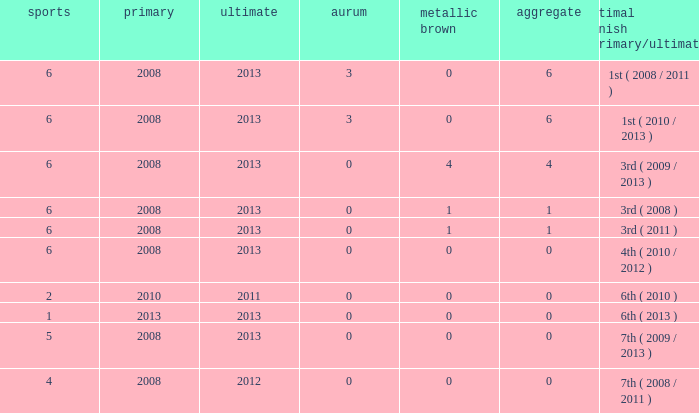Could you parse the entire table as a dict? {'header': ['sports', 'primary', 'ultimate', 'aurum', 'metallic brown', 'aggregate', 'optimal finish (primary/ultimate)'], 'rows': [['6', '2008', '2013', '3', '0', '6', '1st ( 2008 / 2011 )'], ['6', '2008', '2013', '3', '0', '6', '1st ( 2010 / 2013 )'], ['6', '2008', '2013', '0', '4', '4', '3rd ( 2009 / 2013 )'], ['6', '2008', '2013', '0', '1', '1', '3rd ( 2008 )'], ['6', '2008', '2013', '0', '1', '1', '3rd ( 2011 )'], ['6', '2008', '2013', '0', '0', '0', '4th ( 2010 / 2012 )'], ['2', '2010', '2011', '0', '0', '0', '6th ( 2010 )'], ['1', '2013', '2013', '0', '0', '0', '6th ( 2013 )'], ['5', '2008', '2013', '0', '0', '0', '7th ( 2009 / 2013 )'], ['4', '2008', '2012', '0', '0', '0', '7th ( 2008 / 2011 )']]} How many bronzes associated with over 0 total medals, 3 golds, and over 6 games? None. 